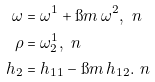Convert formula to latex. <formula><loc_0><loc_0><loc_500><loc_500>\omega & = \omega ^ { 1 } + \i m \, \omega ^ { 2 } , \ n \\ \rho & = \omega ^ { 1 } _ { 2 } , \ n \\ h _ { 2 } & = h _ { 1 1 } - \i m \, h _ { 1 2 } . \ n</formula> 